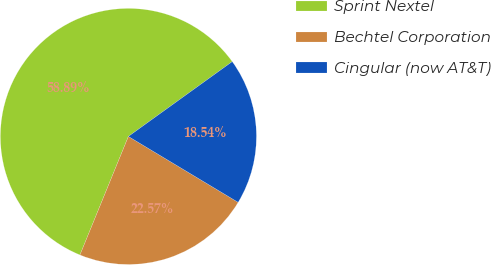Convert chart to OTSL. <chart><loc_0><loc_0><loc_500><loc_500><pie_chart><fcel>Sprint Nextel<fcel>Bechtel Corporation<fcel>Cingular (now AT&T)<nl><fcel>58.88%<fcel>22.57%<fcel>18.54%<nl></chart> 